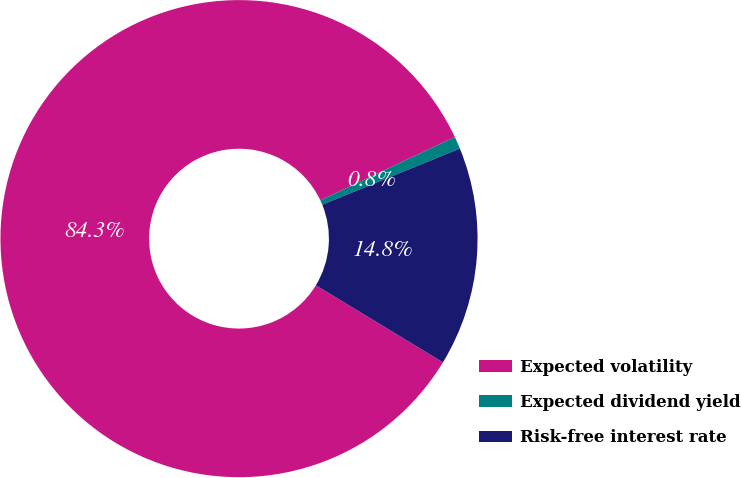Convert chart. <chart><loc_0><loc_0><loc_500><loc_500><pie_chart><fcel>Expected volatility<fcel>Expected dividend yield<fcel>Risk-free interest rate<nl><fcel>84.32%<fcel>0.84%<fcel>14.84%<nl></chart> 